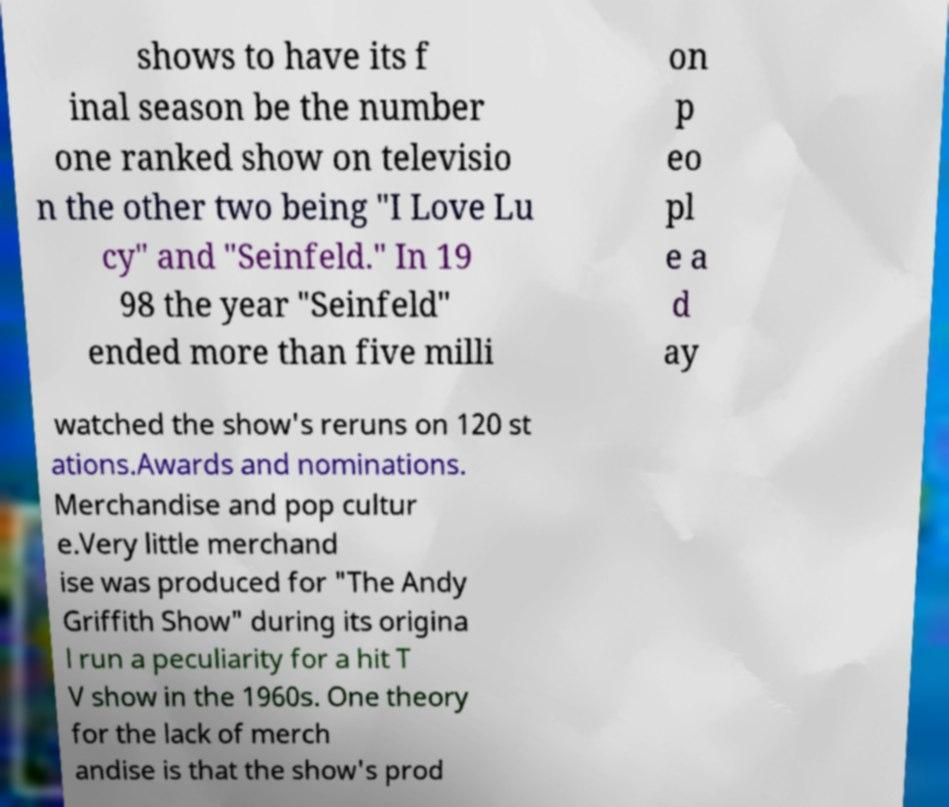There's text embedded in this image that I need extracted. Can you transcribe it verbatim? shows to have its f inal season be the number one ranked show on televisio n the other two being "I Love Lu cy" and "Seinfeld." In 19 98 the year "Seinfeld" ended more than five milli on p eo pl e a d ay watched the show's reruns on 120 st ations.Awards and nominations. Merchandise and pop cultur e.Very little merchand ise was produced for "The Andy Griffith Show" during its origina l run a peculiarity for a hit T V show in the 1960s. One theory for the lack of merch andise is that the show's prod 